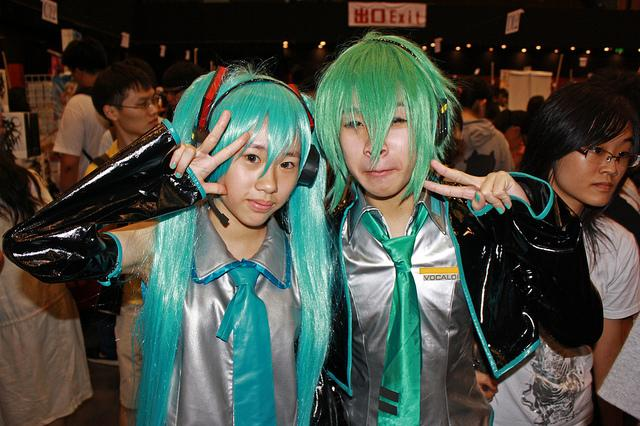What hand gesture are the two doing? Please explain your reasoning. peace sign. The hand gesture is a peace sign. 